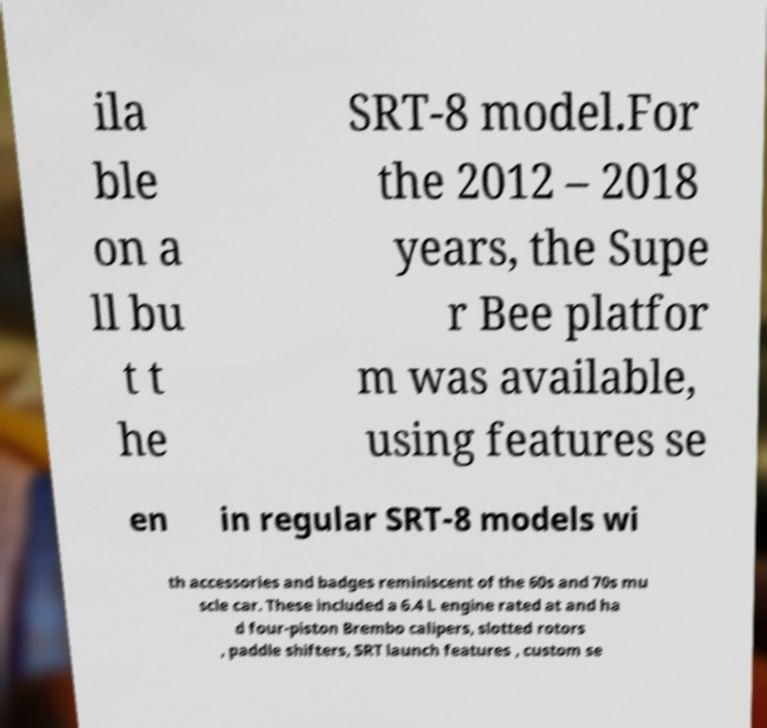Can you read and provide the text displayed in the image?This photo seems to have some interesting text. Can you extract and type it out for me? ila ble on a ll bu t t he SRT-8 model.For the 2012 – 2018 years, the Supe r Bee platfor m was available, using features se en in regular SRT-8 models wi th accessories and badges reminiscent of the 60s and 70s mu scle car. These included a 6.4 L engine rated at and ha d four-piston Brembo calipers, slotted rotors , paddle shifters, SRT launch features , custom se 